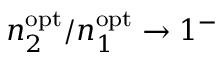Convert formula to latex. <formula><loc_0><loc_0><loc_500><loc_500>n _ { 2 } ^ { o p t } / n _ { 1 } ^ { o p t } \to 1 ^ { - }</formula> 